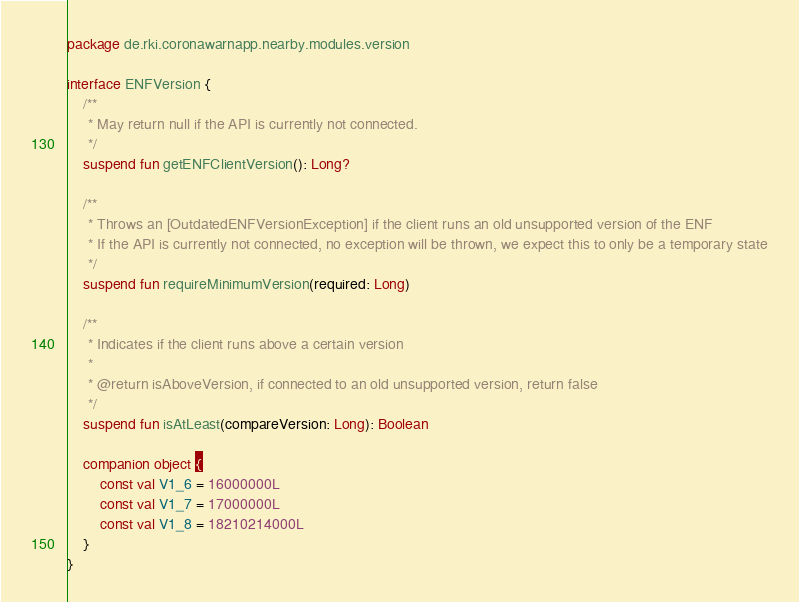Convert code to text. <code><loc_0><loc_0><loc_500><loc_500><_Kotlin_>package de.rki.coronawarnapp.nearby.modules.version

interface ENFVersion {
    /**
     * May return null if the API is currently not connected.
     */
    suspend fun getENFClientVersion(): Long?

    /**
     * Throws an [OutdatedENFVersionException] if the client runs an old unsupported version of the ENF
     * If the API is currently not connected, no exception will be thrown, we expect this to only be a temporary state
     */
    suspend fun requireMinimumVersion(required: Long)

    /**
     * Indicates if the client runs above a certain version
     *
     * @return isAboveVersion, if connected to an old unsupported version, return false
     */
    suspend fun isAtLeast(compareVersion: Long): Boolean

    companion object {
        const val V1_6 = 16000000L
        const val V1_7 = 17000000L
        const val V1_8 = 18210214000L
    }
}
</code> 